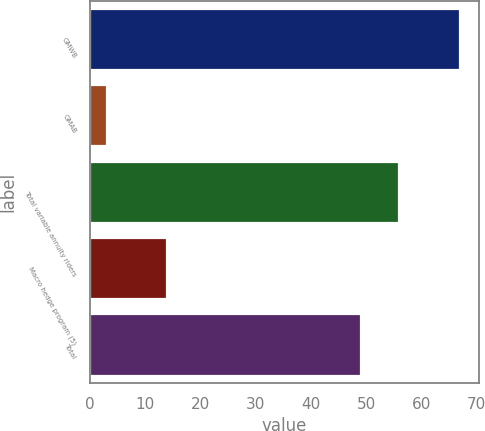<chart> <loc_0><loc_0><loc_500><loc_500><bar_chart><fcel>GMWB<fcel>GMAB<fcel>Total variable annuity riders<fcel>Macro hedge program (5)<fcel>Total<nl><fcel>67<fcel>3<fcel>56<fcel>14<fcel>49<nl></chart> 